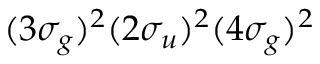Convert formula to latex. <formula><loc_0><loc_0><loc_500><loc_500>( 3 \sigma _ { g } ) ^ { 2 } ( 2 \sigma _ { u } ) ^ { 2 } ( 4 \sigma _ { g } ) ^ { 2 }</formula> 